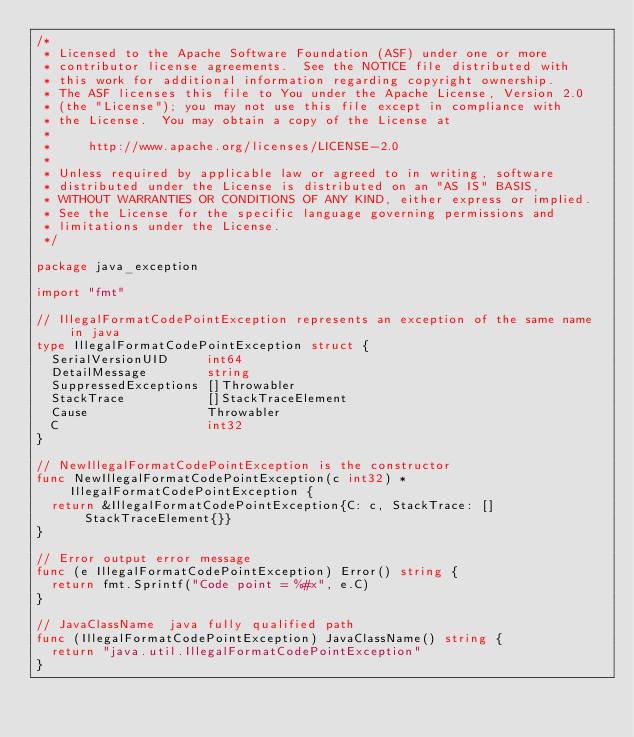Convert code to text. <code><loc_0><loc_0><loc_500><loc_500><_Go_>/*
 * Licensed to the Apache Software Foundation (ASF) under one or more
 * contributor license agreements.  See the NOTICE file distributed with
 * this work for additional information regarding copyright ownership.
 * The ASF licenses this file to You under the Apache License, Version 2.0
 * (the "License"); you may not use this file except in compliance with
 * the License.  You may obtain a copy of the License at
 *
 *     http://www.apache.org/licenses/LICENSE-2.0
 *
 * Unless required by applicable law or agreed to in writing, software
 * distributed under the License is distributed on an "AS IS" BASIS,
 * WITHOUT WARRANTIES OR CONDITIONS OF ANY KIND, either express or implied.
 * See the License for the specific language governing permissions and
 * limitations under the License.
 */

package java_exception

import "fmt"

// IllegalFormatCodePointException represents an exception of the same name in java
type IllegalFormatCodePointException struct {
	SerialVersionUID     int64
	DetailMessage        string
	SuppressedExceptions []Throwabler
	StackTrace           []StackTraceElement
	Cause                Throwabler
	C                    int32
}

// NewIllegalFormatCodePointException is the constructor
func NewIllegalFormatCodePointException(c int32) *IllegalFormatCodePointException {
	return &IllegalFormatCodePointException{C: c, StackTrace: []StackTraceElement{}}
}

// Error output error message
func (e IllegalFormatCodePointException) Error() string {
	return fmt.Sprintf("Code point = %#x", e.C)
}

// JavaClassName  java fully qualified path
func (IllegalFormatCodePointException) JavaClassName() string {
	return "java.util.IllegalFormatCodePointException"
}
</code> 